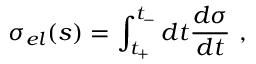<formula> <loc_0><loc_0><loc_500><loc_500>\sigma _ { e l } ( s ) = \int _ { t _ { + } } ^ { t _ { - } } d t { \frac { d \sigma } { d t } } ,</formula> 